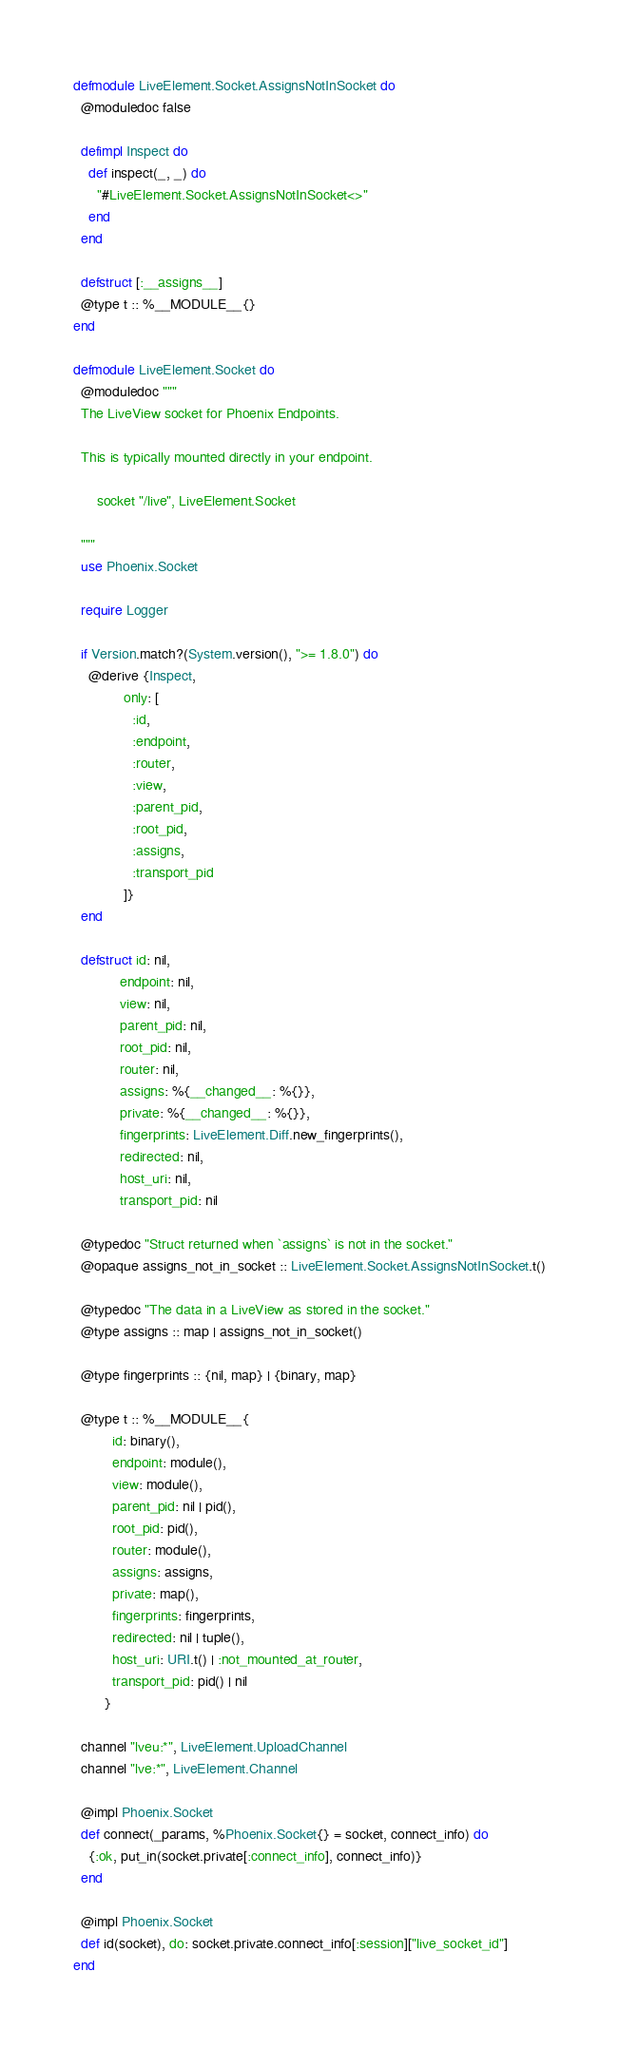<code> <loc_0><loc_0><loc_500><loc_500><_Elixir_>defmodule LiveElement.Socket.AssignsNotInSocket do
  @moduledoc false

  defimpl Inspect do
    def inspect(_, _) do
      "#LiveElement.Socket.AssignsNotInSocket<>"
    end
  end

  defstruct [:__assigns__]
  @type t :: %__MODULE__{}
end

defmodule LiveElement.Socket do
  @moduledoc """
  The LiveView socket for Phoenix Endpoints.

  This is typically mounted directly in your endpoint.

      socket "/live", LiveElement.Socket

  """
  use Phoenix.Socket

  require Logger

  if Version.match?(System.version(), ">= 1.8.0") do
    @derive {Inspect,
             only: [
               :id,
               :endpoint,
               :router,
               :view,
               :parent_pid,
               :root_pid,
               :assigns,
               :transport_pid
             ]}
  end

  defstruct id: nil,
            endpoint: nil,
            view: nil,
            parent_pid: nil,
            root_pid: nil,
            router: nil,
            assigns: %{__changed__: %{}},
            private: %{__changed__: %{}},
            fingerprints: LiveElement.Diff.new_fingerprints(),
            redirected: nil,
            host_uri: nil,
            transport_pid: nil

  @typedoc "Struct returned when `assigns` is not in the socket."
  @opaque assigns_not_in_socket :: LiveElement.Socket.AssignsNotInSocket.t()

  @typedoc "The data in a LiveView as stored in the socket."
  @type assigns :: map | assigns_not_in_socket()

  @type fingerprints :: {nil, map} | {binary, map}

  @type t :: %__MODULE__{
          id: binary(),
          endpoint: module(),
          view: module(),
          parent_pid: nil | pid(),
          root_pid: pid(),
          router: module(),
          assigns: assigns,
          private: map(),
          fingerprints: fingerprints,
          redirected: nil | tuple(),
          host_uri: URI.t() | :not_mounted_at_router,
          transport_pid: pid() | nil
        }

  channel "lveu:*", LiveElement.UploadChannel
  channel "lve:*", LiveElement.Channel

  @impl Phoenix.Socket
  def connect(_params, %Phoenix.Socket{} = socket, connect_info) do
    {:ok, put_in(socket.private[:connect_info], connect_info)}
  end

  @impl Phoenix.Socket
  def id(socket), do: socket.private.connect_info[:session]["live_socket_id"]
end
</code> 